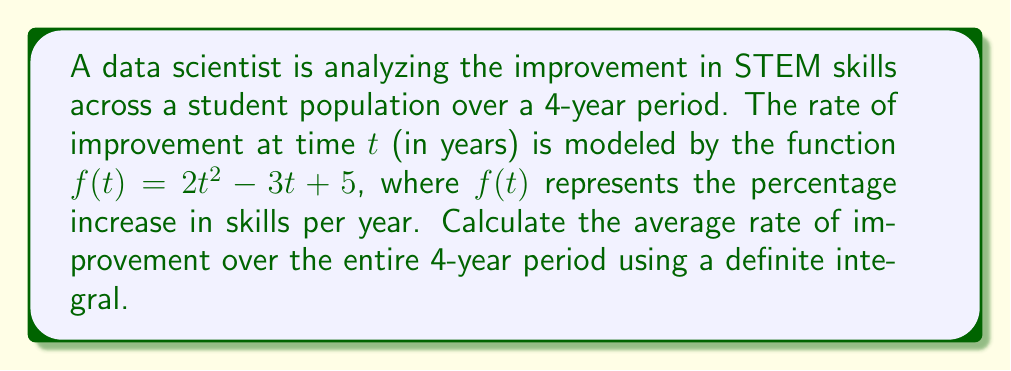Provide a solution to this math problem. To find the average rate of improvement over the 4-year period, we need to:

1. Calculate the definite integral of the rate function $f(t)$ from $t=0$ to $t=4$.
2. Divide the result by the length of the time interval (4 years).

Step 1: Evaluate the definite integral

$$\int_0^4 f(t) dt = \int_0^4 (2t^2 - 3t + 5) dt$$

Using the power rule and constant rule of integration:

$$\int_0^4 (2t^2 - 3t + 5) dt = \left[\frac{2t^3}{3} - \frac{3t^2}{2} + 5t\right]_0^4$$

Evaluating at the limits:

$$\left[\frac{2(4^3)}{3} - \frac{3(4^2)}{2} + 5(4)\right] - \left[\frac{2(0^3)}{3} - \frac{3(0^2)}{2} + 5(0)\right]$$

$$= \left[\frac{128}{3} - 24 + 20\right] - [0] = \frac{128}{3} - 4 = \frac{116}{3}$$

Step 2: Divide by the time interval

The average rate of improvement is:

$$\text{Average Rate} = \frac{\int_0^4 f(t) dt}{4} = \frac{116/3}{4} = \frac{29}{3}$$

Therefore, the average rate of improvement over the 4-year period is $\frac{29}{3}$ percent per year.
Answer: $\frac{29}{3}$ percent per year 